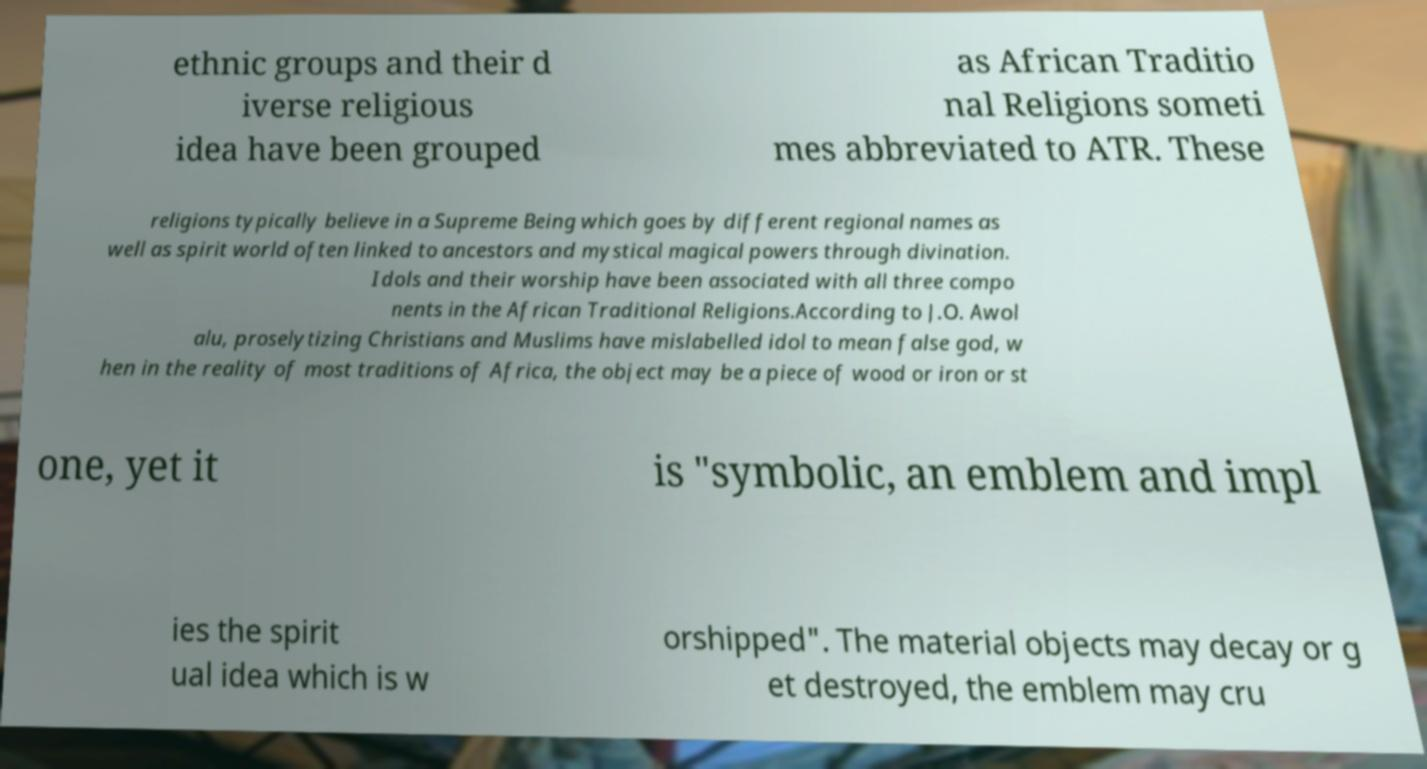I need the written content from this picture converted into text. Can you do that? ethnic groups and their d iverse religious idea have been grouped as African Traditio nal Religions someti mes abbreviated to ATR. These religions typically believe in a Supreme Being which goes by different regional names as well as spirit world often linked to ancestors and mystical magical powers through divination. Idols and their worship have been associated with all three compo nents in the African Traditional Religions.According to J.O. Awol alu, proselytizing Christians and Muslims have mislabelled idol to mean false god, w hen in the reality of most traditions of Africa, the object may be a piece of wood or iron or st one, yet it is "symbolic, an emblem and impl ies the spirit ual idea which is w orshipped". The material objects may decay or g et destroyed, the emblem may cru 